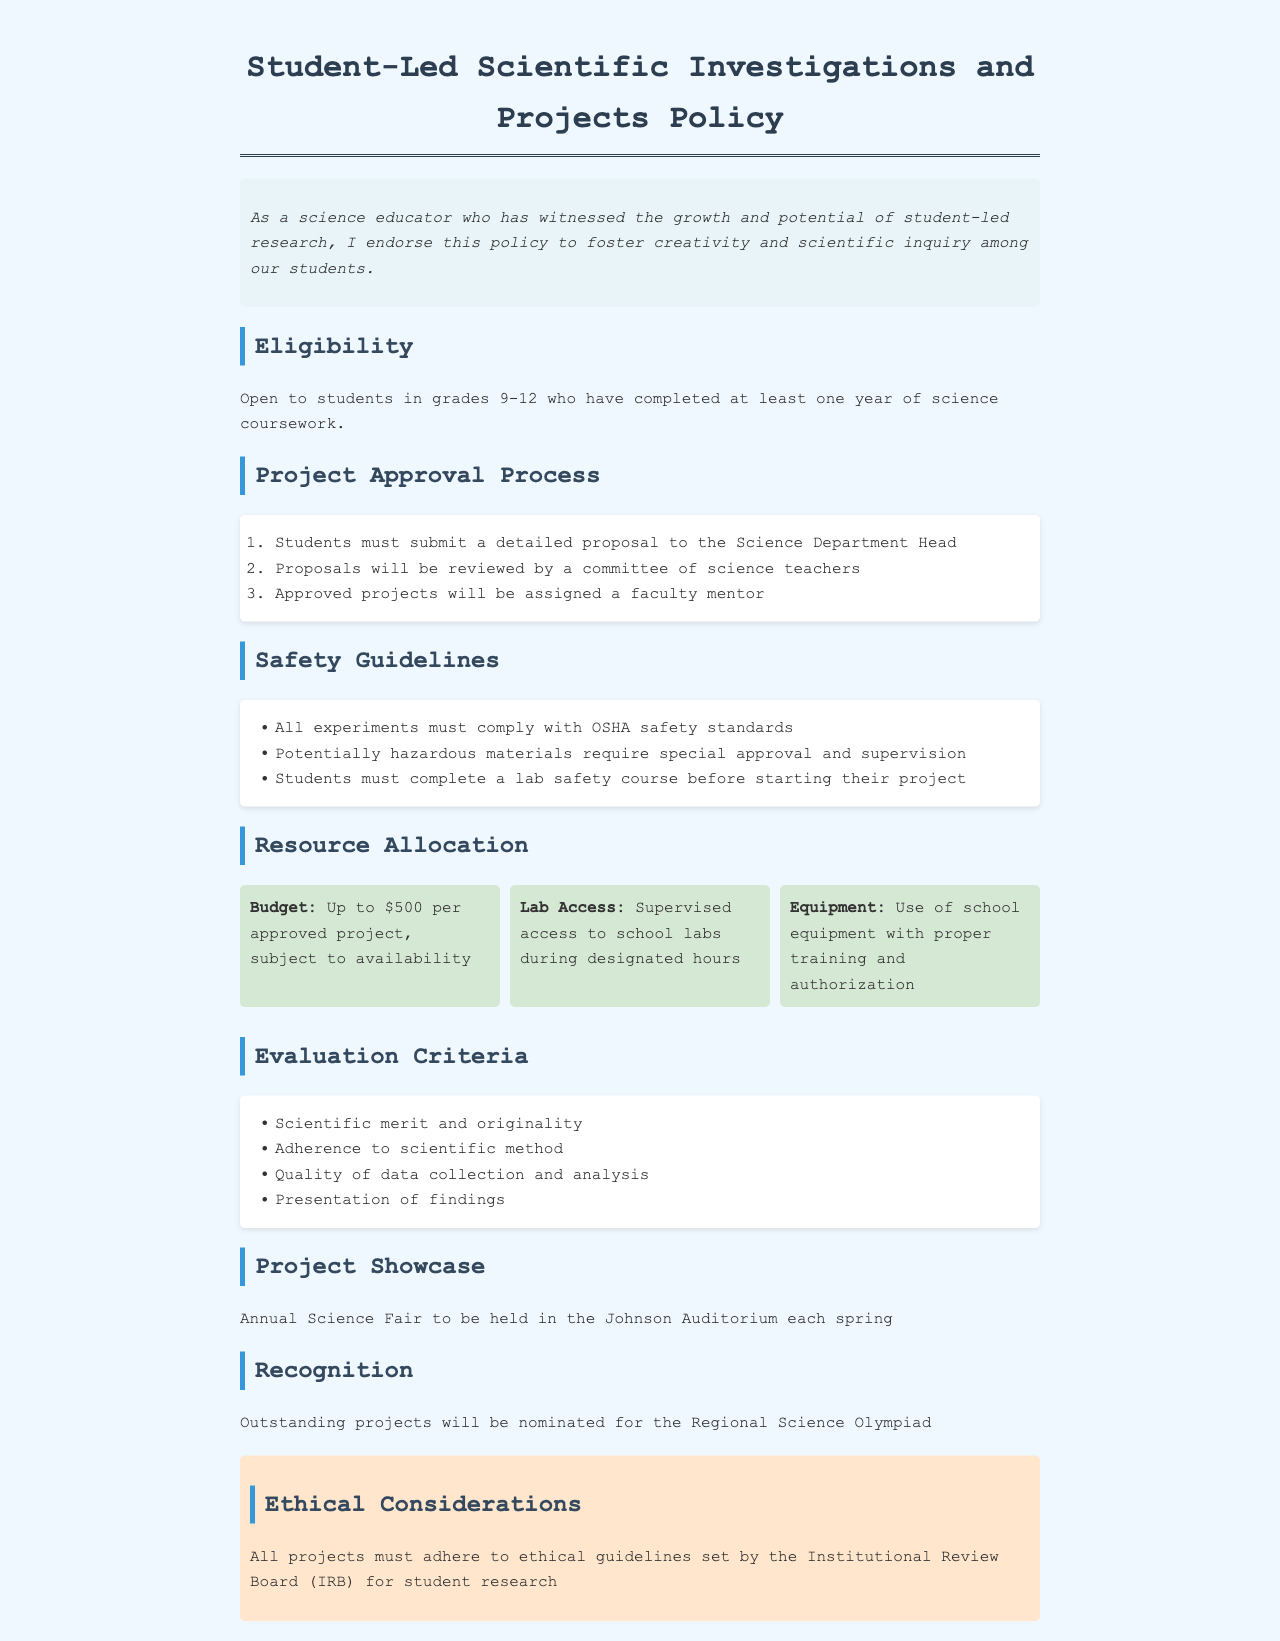What grades are eligible for student-led projects? The eligibility criteria state that students in grades 9-12 can participate, provided they have completed at least one year of science coursework.
Answer: Grades 9-12 What is the budget limit for approved projects? The policy specifies that each approved project can receive a budget of up to $500, depending on availability.
Answer: Up to $500 What must students do before starting their project? Students are required to complete a lab safety course before they can begin their projects.
Answer: Complete a lab safety course Where will the annual Science Fair be held? The document mentions that the Science Fair is to be held in the Johnson Auditorium each spring.
Answer: Johnson Auditorium What is one evaluation criterion for the projects? One of the criteria for evaluating projects is the scientific merit and originality.
Answer: Scientific merit and originality Who will review the project proposals? The proposals will be reviewed by a committee of science teachers.
Answer: Committee of science teachers What must all projects adhere to according to ethical considerations? The projects must adhere to the ethical guidelines set by the Institutional Review Board for student research.
Answer: Institutional Review Board (IRB) What happens to outstanding projects? Outstanding projects will be nominated for the Regional Science Olympiad as recognition.
Answer: Nominated for the Regional Science Olympiad 